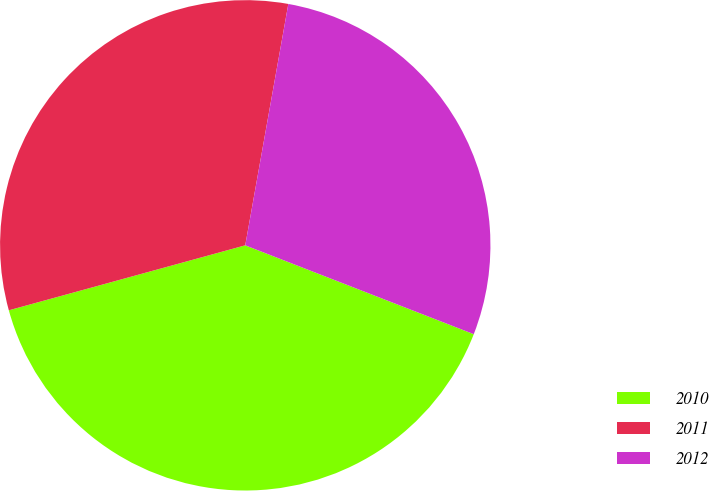Convert chart to OTSL. <chart><loc_0><loc_0><loc_500><loc_500><pie_chart><fcel>2010<fcel>2011<fcel>2012<nl><fcel>39.83%<fcel>32.08%<fcel>28.09%<nl></chart> 